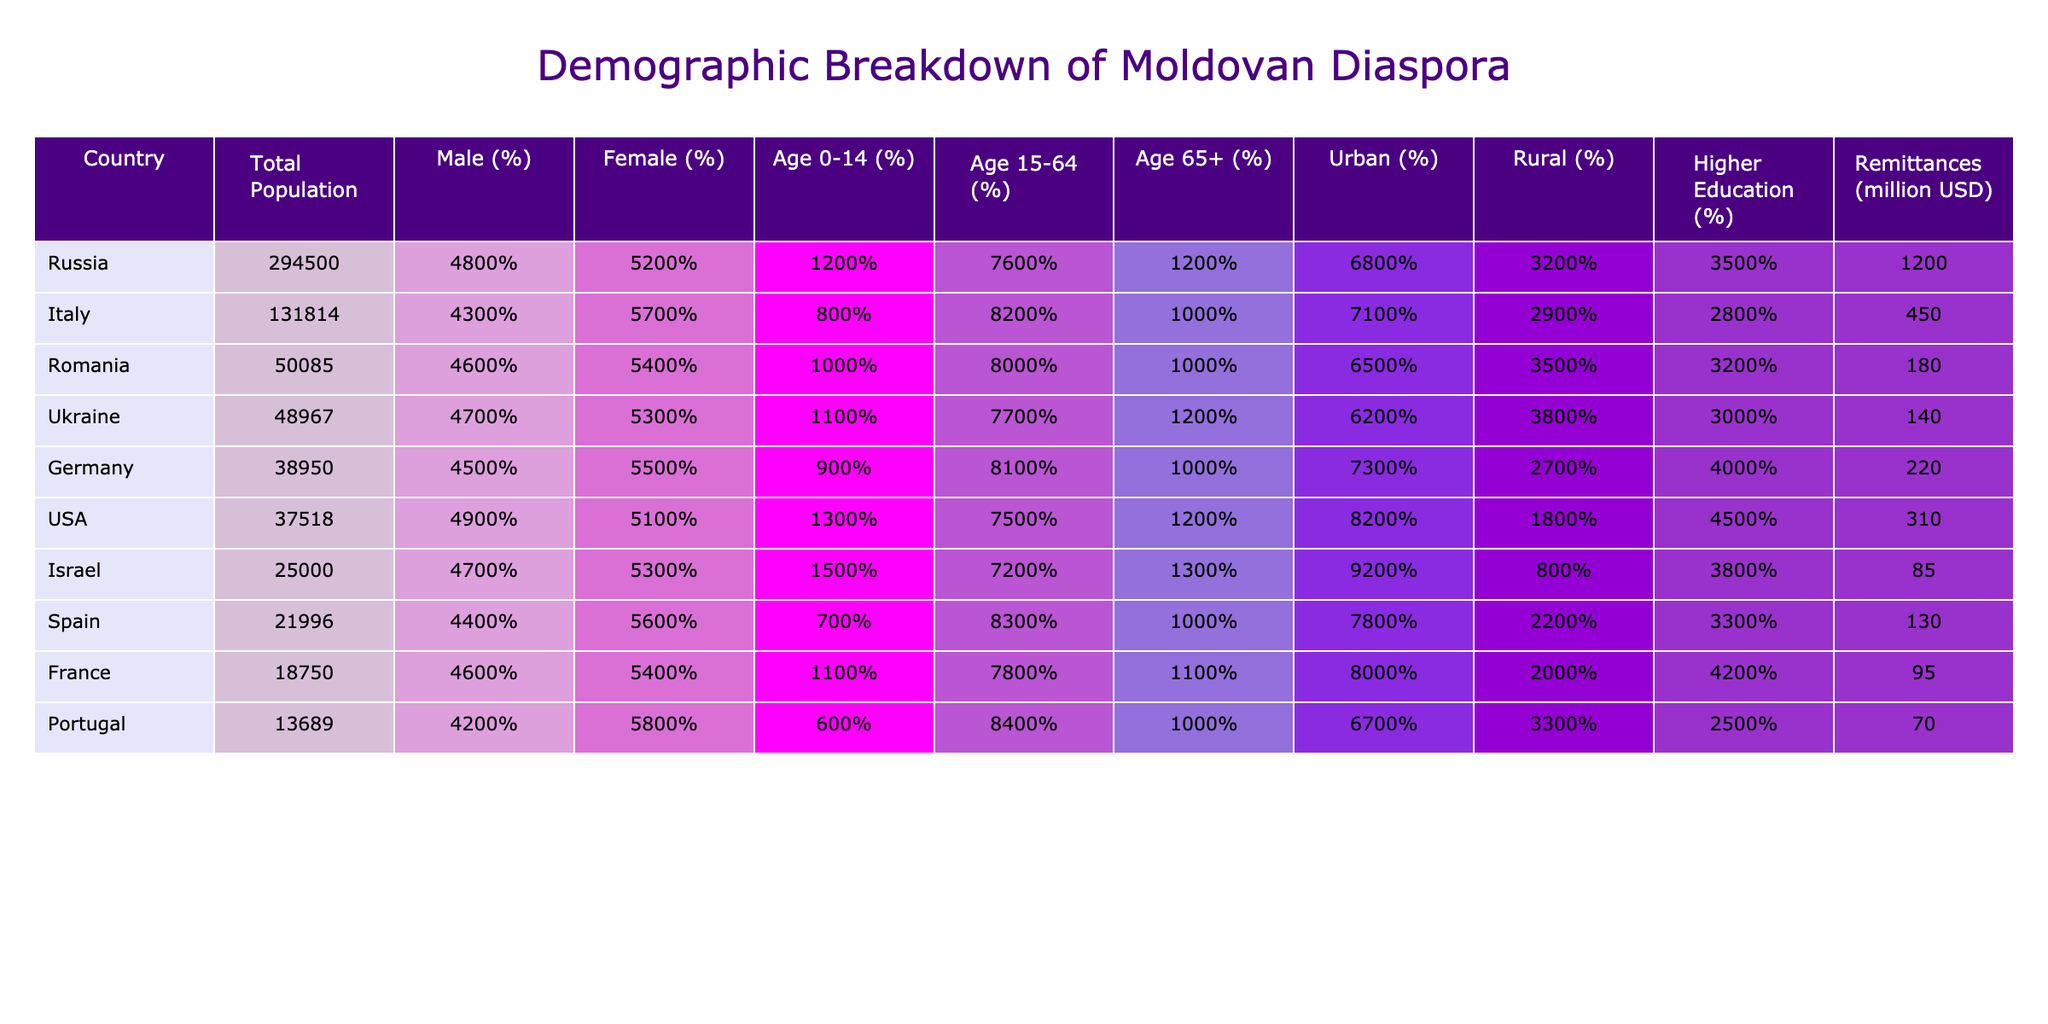What is the total population of Moldovan diaspora in Italy? The table shows that the total population in Italy is 131,814.
Answer: 131,814 Which country has the highest percentage of males in the Moldovan diaspora? By comparing the male percentages across the countries, we see the highest is in Ukraine at 47%.
Answer: Ukraine, 47% What percentage of the Moldovan diaspora in Germany is aged 65 and older? The table indicates that 10% of the population in Germany is aged 65 and older.
Answer: 10% What is the total remittances sent from the Moldovan diaspora in the USA? The USA has total remittances amounting to 310 million USD, according to the table.
Answer: 310 million USD Which country has the highest percentage of the 0-14 year age group in the Moldovan diaspora? Reviewing the data, Israel has the highest percentage at 15% for the age 0-14 group.
Answer: Israel, 15% Are there more males or females in the Moldovan diaspora in Russia? In Russia, the percentage of females is 52%, which is higher than males at 48%. Therefore, there are more females.
Answer: More females What is the average percentage of the population aged 15-64 across all listed countries? Adding the percentages for all countries (76 + 82 + 80 + 77 + 81 + 75 + 72 + 83 + 78 + 84) = 786. This is divided by 10 (the number of countries), resulting in an average of 78.6%.
Answer: 78.6% Is the percentage of higher education holders in rural areas overall higher than in urban areas? Urban areas show higher education percentages (average 39.1%) than rural areas (average 31.8%) across listed countries. This means urban areas have a higher percentage overall.
Answer: No, rural is lower What country had both the highest urban population percentage and the highest total remittances? The USA has the highest urban population percentage at 82% and also sends the highest remittances of 310 million USD.
Answer: USA How does the urban population percentage of Moldova diaspora in Italy compare to that of Portugal? Italy has 71% while Portugal has 67% for urban population percentage. Italy's urban population percentage is higher than Portugal's.
Answer: Italy is higher 